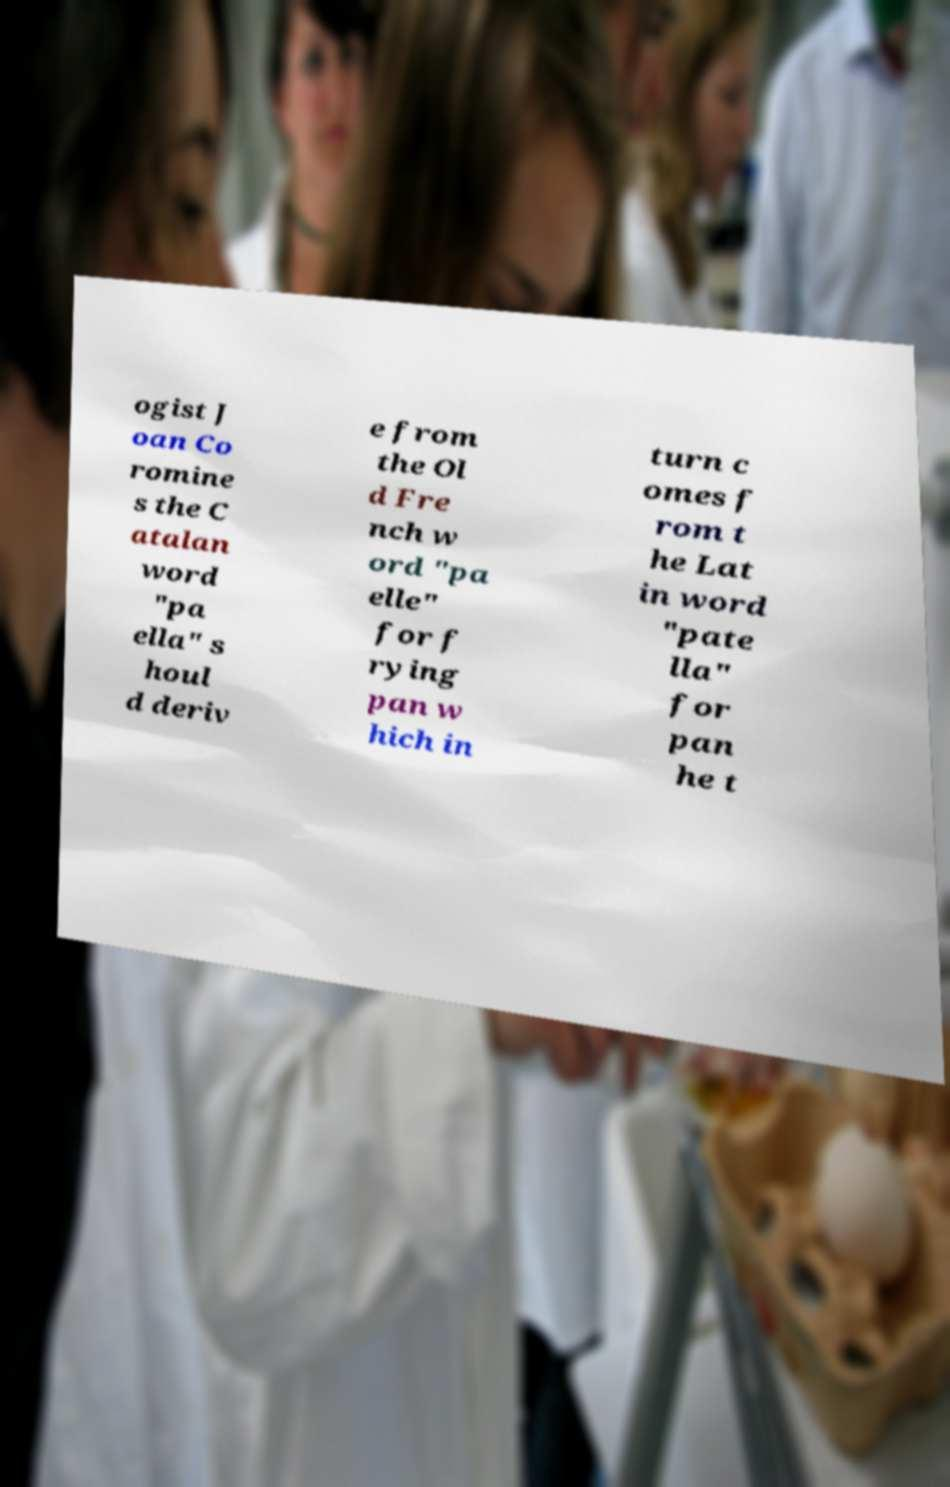Please identify and transcribe the text found in this image. ogist J oan Co romine s the C atalan word "pa ella" s houl d deriv e from the Ol d Fre nch w ord "pa elle" for f rying pan w hich in turn c omes f rom t he Lat in word "pate lla" for pan he t 